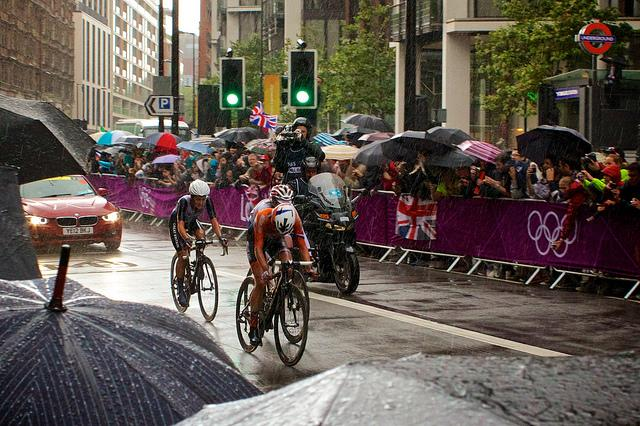When was the Union Jack invented? 1606 